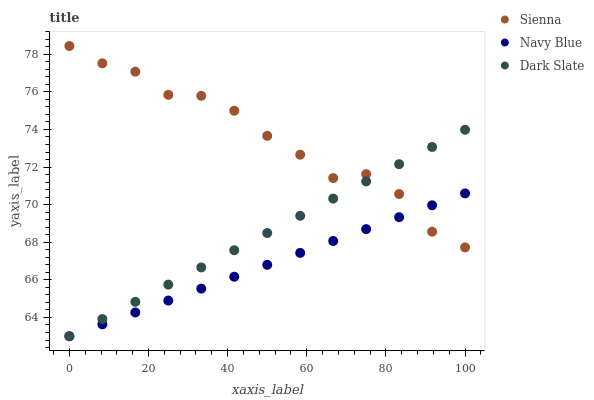Does Navy Blue have the minimum area under the curve?
Answer yes or no. Yes. Does Sienna have the maximum area under the curve?
Answer yes or no. Yes. Does Dark Slate have the minimum area under the curve?
Answer yes or no. No. Does Dark Slate have the maximum area under the curve?
Answer yes or no. No. Is Navy Blue the smoothest?
Answer yes or no. Yes. Is Sienna the roughest?
Answer yes or no. Yes. Is Dark Slate the smoothest?
Answer yes or no. No. Is Dark Slate the roughest?
Answer yes or no. No. Does Navy Blue have the lowest value?
Answer yes or no. Yes. Does Sienna have the highest value?
Answer yes or no. Yes. Does Dark Slate have the highest value?
Answer yes or no. No. Does Navy Blue intersect Dark Slate?
Answer yes or no. Yes. Is Navy Blue less than Dark Slate?
Answer yes or no. No. Is Navy Blue greater than Dark Slate?
Answer yes or no. No. 